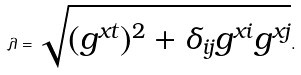Convert formula to latex. <formula><loc_0><loc_0><loc_500><loc_500>\lambda = \sqrt { ( { g ^ { x t } } ) ^ { 2 } + \delta _ { i j } g ^ { x i } g ^ { x j } } .</formula> 